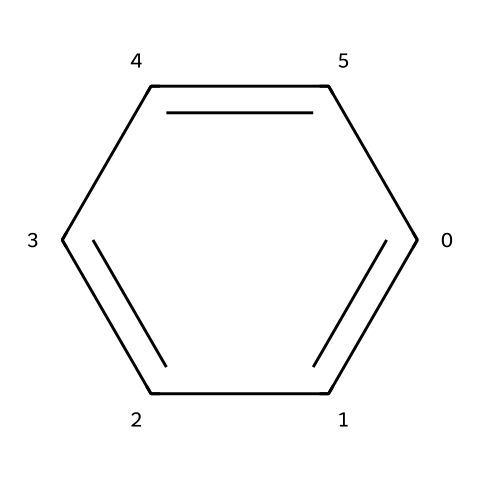What is the chemical name represented by this structure? The SMILES representation corresponds to a common aromatic compound known as benzene, which has a unique hexagonal structure with alternating double bonds.
Answer: benzene How many carbon atoms are in the structure? Analyzing the structure, it shows a hexagonal arrangement with one atom at each vertex, indicating there are six carbon atoms making up the benzene ring.
Answer: 6 How many hydrogen atoms are attached to the benzene? Each carbon in the benzene structure is bonded to one hydrogen atom, resulting in a total of six hydrogen atoms bonded to the six carbon atoms in the benzene ring.
Answer: 6 Is benzene classified as a volatile organic compound? Benzene is recognized for its volatility and is classified as a volatile organic compound (VOC) due to its ability to easily evaporate into the air at room temperature.
Answer: yes What type of bonding is present in the benzene structure? The benzene structure demonstrates resonance with alternating double bonds, indicating that it consists of both single and double bonds forming a stable aromatic ring through delocalized electrons.
Answer: resonance What is a major health concern associated with exposure to benzene? Prolonged exposure to benzene has been linked to serious health issues, notably its classification as a carcinogen that can lead to leukemia and other blood disorders.
Answer: carcinogen 